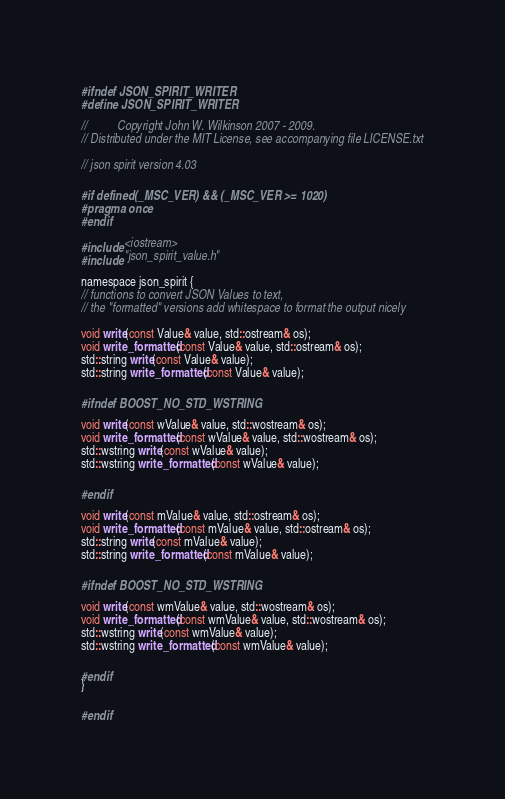<code> <loc_0><loc_0><loc_500><loc_500><_C_>#ifndef JSON_SPIRIT_WRITER
#define JSON_SPIRIT_WRITER

//          Copyright John W. Wilkinson 2007 - 2009.
// Distributed under the MIT License, see accompanying file LICENSE.txt

// json spirit version 4.03

#if defined(_MSC_VER) && (_MSC_VER >= 1020)
#pragma once
#endif

#include <iostream>
#include "json_spirit_value.h"

namespace json_spirit {
// functions to convert JSON Values to text,
// the "formatted" versions add whitespace to format the output nicely

void write(const Value& value, std::ostream& os);
void write_formatted(const Value& value, std::ostream& os);
std::string write(const Value& value);
std::string write_formatted(const Value& value);

#ifndef BOOST_NO_STD_WSTRING

void write(const wValue& value, std::wostream& os);
void write_formatted(const wValue& value, std::wostream& os);
std::wstring write(const wValue& value);
std::wstring write_formatted(const wValue& value);

#endif

void write(const mValue& value, std::ostream& os);
void write_formatted(const mValue& value, std::ostream& os);
std::string write(const mValue& value);
std::string write_formatted(const mValue& value);

#ifndef BOOST_NO_STD_WSTRING

void write(const wmValue& value, std::wostream& os);
void write_formatted(const wmValue& value, std::wostream& os);
std::wstring write(const wmValue& value);
std::wstring write_formatted(const wmValue& value);

#endif
}

#endif
</code> 